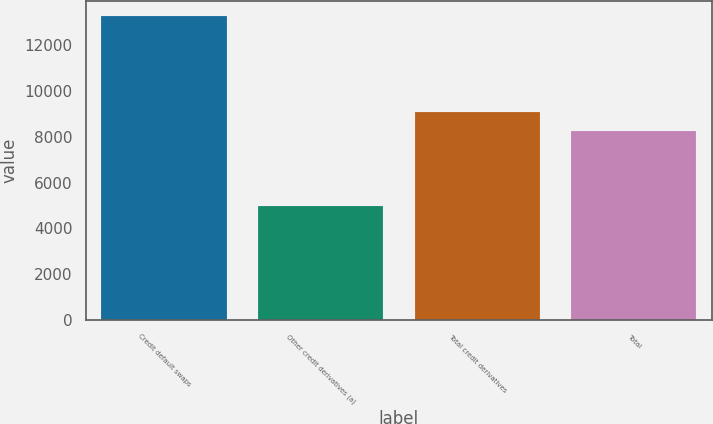Convert chart to OTSL. <chart><loc_0><loc_0><loc_500><loc_500><bar_chart><fcel>Credit default swaps<fcel>Other credit derivatives (a)<fcel>Total credit derivatives<fcel>Total<nl><fcel>13249<fcel>4970<fcel>9065.9<fcel>8238<nl></chart> 